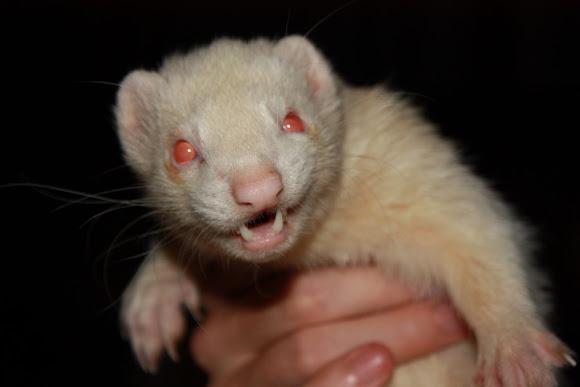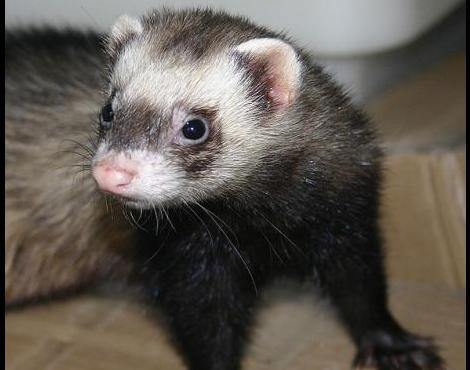The first image is the image on the left, the second image is the image on the right. Evaluate the accuracy of this statement regarding the images: "The right image contains exactly one ferret.". Is it true? Answer yes or no. Yes. The first image is the image on the left, the second image is the image on the right. For the images shown, is this caption "The right image contains twice as many ferrets as the left image." true? Answer yes or no. No. 